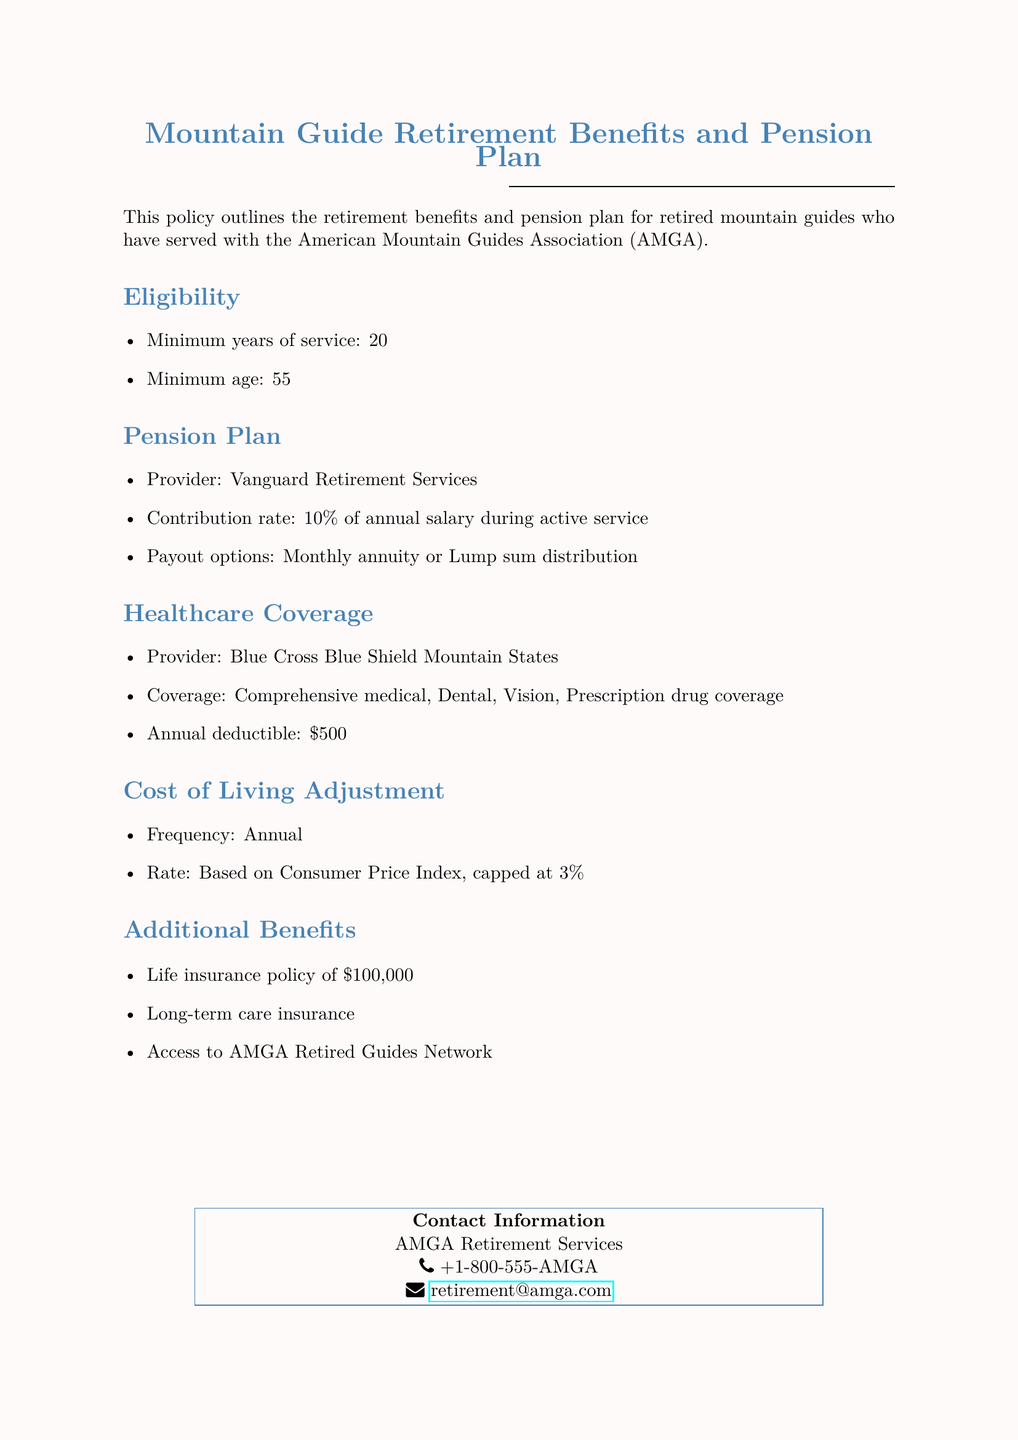What is the minimum years of service required for eligibility? The document states that a minimum of 20 years of service is required for eligibility.
Answer: 20 What is the minimum age for eligibility? The document specifies that the minimum age for eligibility is 55.
Answer: 55 Who is the provider for the pension plan? The document mentions that the pension plan provider is Vanguard Retirement Services.
Answer: Vanguard Retirement Services What percentage of the annual salary is the contribution rate during active service? The document details that the contribution rate is 10% of annual salary during active service.
Answer: 10% What is the annual deductible for healthcare coverage? The document states that the annual deductible for healthcare coverage is $500.
Answer: $500 What is the capped rate for the cost of living adjustment? The document indicates that the cost of living adjustment is capped at 3%.
Answer: 3% What type of insurance policy is included in additional benefits? The document mentions a life insurance policy as part of the additional benefits.
Answer: Life insurance policy How often is the cost of living adjustment applied? The document specifies that the cost of living adjustment is applied annually.
Answer: Annual What kind of access do retired guides have as an additional benefit? The document states that retired guides have access to the AMGA Retired Guides Network as an additional benefit.
Answer: AMGA Retired Guides Network 